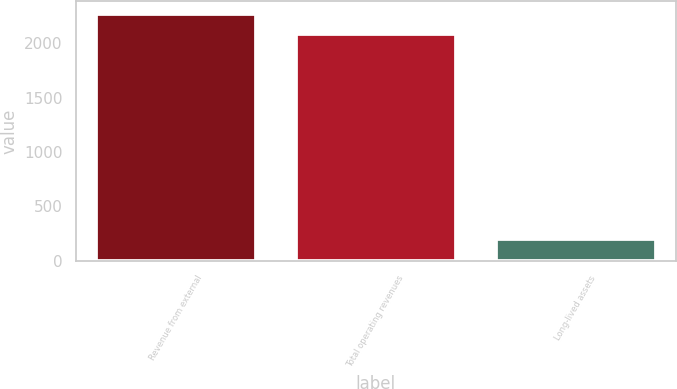<chart> <loc_0><loc_0><loc_500><loc_500><bar_chart><fcel>Revenue from external<fcel>Total operating revenues<fcel>Long-lived assets<nl><fcel>2271.45<fcel>2082.1<fcel>196.7<nl></chart> 